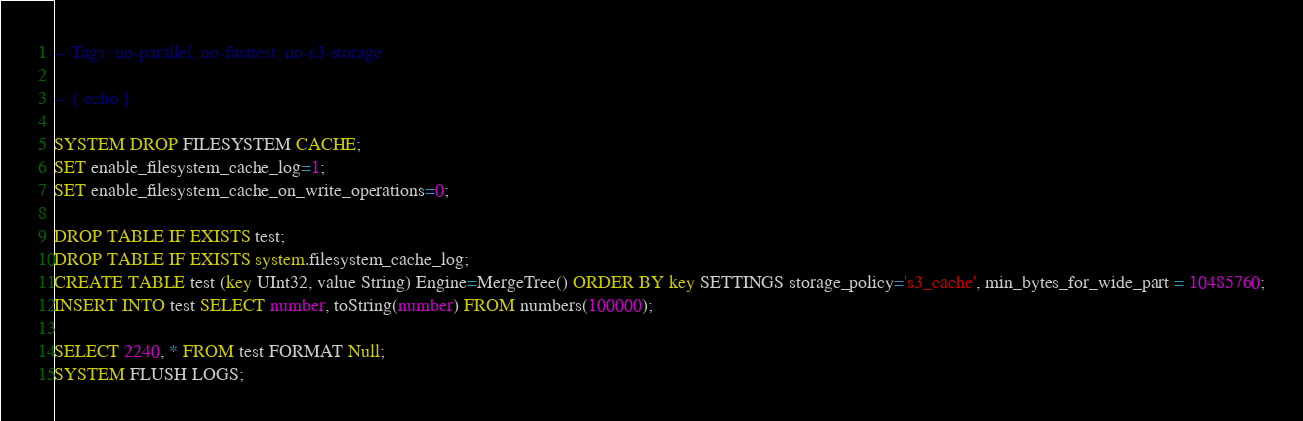Convert code to text. <code><loc_0><loc_0><loc_500><loc_500><_SQL_>-- Tags: no-parallel, no-fasttest, no-s3-storage

-- { echo }

SYSTEM DROP FILESYSTEM CACHE;
SET enable_filesystem_cache_log=1;
SET enable_filesystem_cache_on_write_operations=0;

DROP TABLE IF EXISTS test;
DROP TABLE IF EXISTS system.filesystem_cache_log;
CREATE TABLE test (key UInt32, value String) Engine=MergeTree() ORDER BY key SETTINGS storage_policy='s3_cache', min_bytes_for_wide_part = 10485760;
INSERT INTO test SELECT number, toString(number) FROM numbers(100000);

SELECT 2240, * FROM test FORMAT Null;
SYSTEM FLUSH LOGS;</code> 